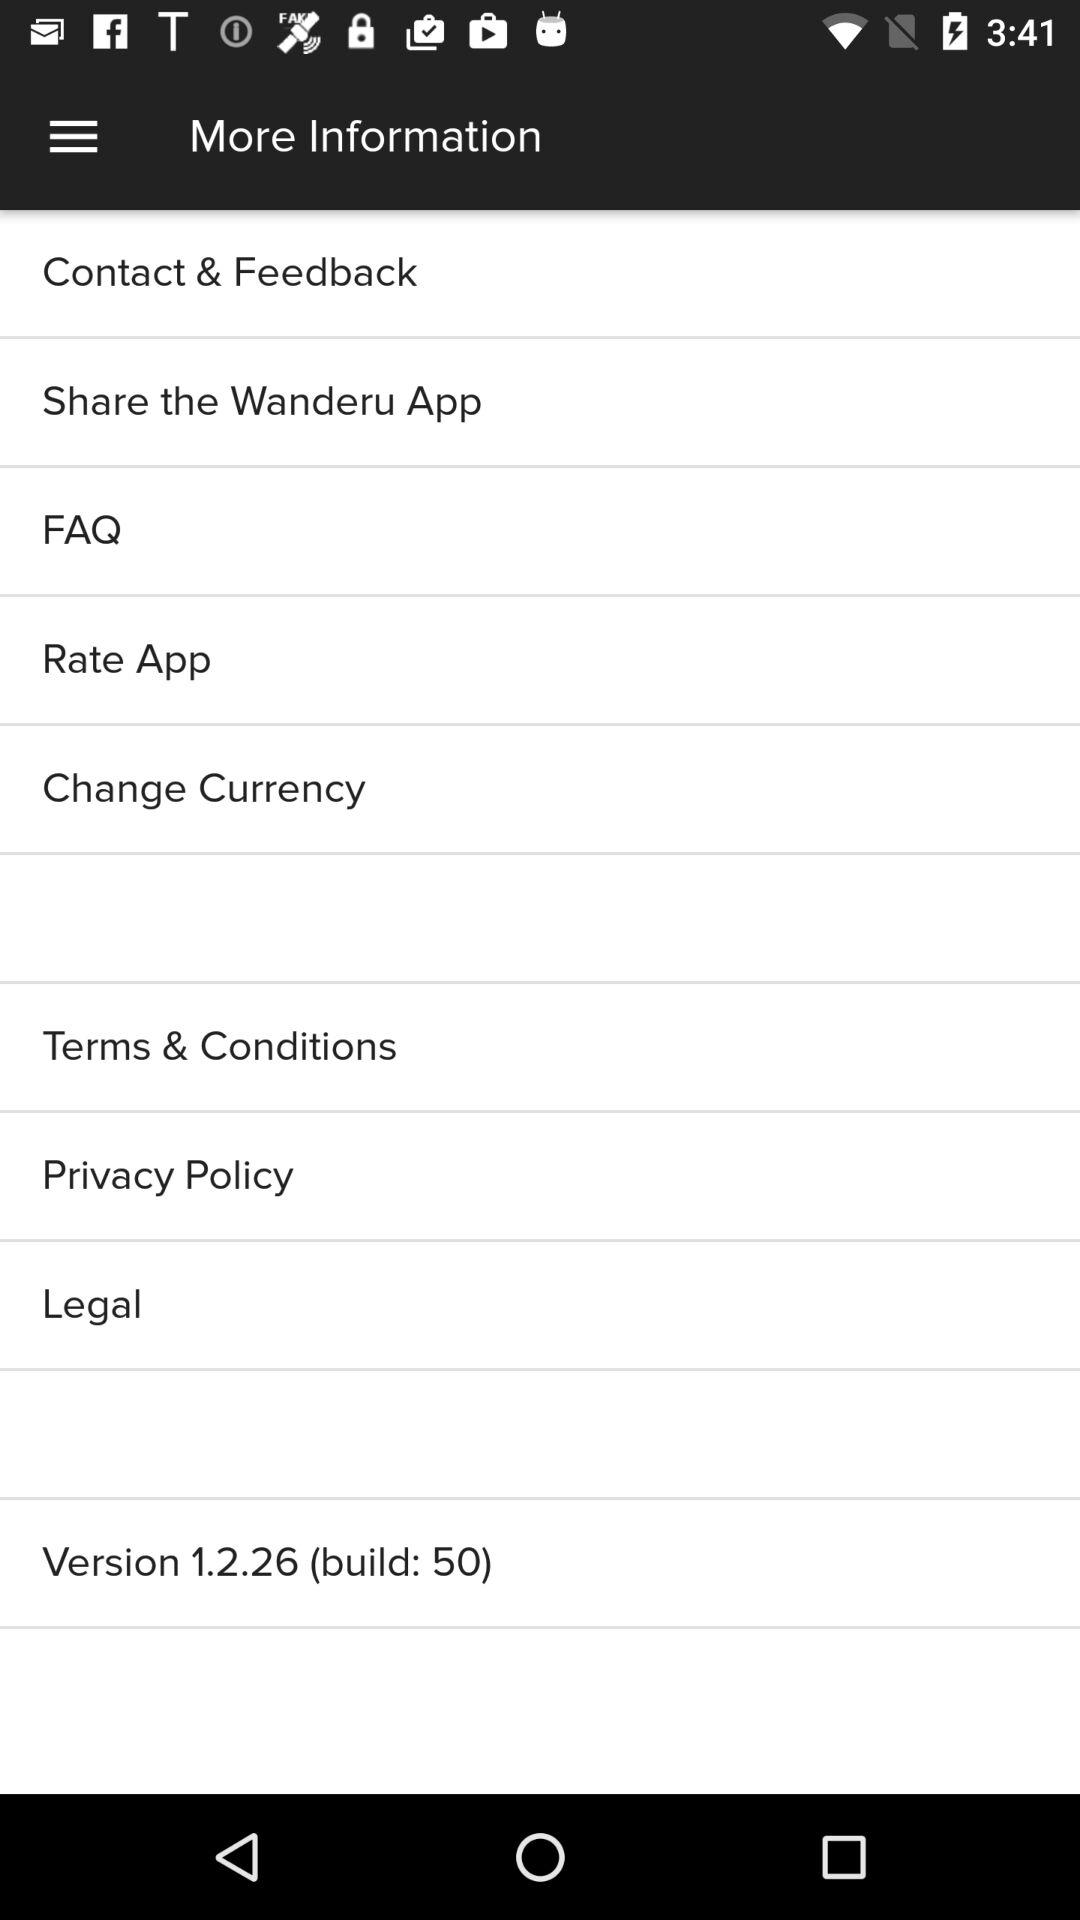Has the user agreed to the terms and conditions?
When the provided information is insufficient, respond with <no answer>. <no answer> 